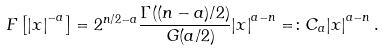Convert formula to latex. <formula><loc_0><loc_0><loc_500><loc_500>\ F \left [ { | x | } ^ { - a } \right ] = { 2 } ^ { n / 2 - a } \frac { \Gamma ( ( n - a ) / 2 ) } { \ G ( a / 2 ) } { | x | } ^ { a - n } = \colon C _ { a } { | x | } ^ { a - n } \, .</formula> 